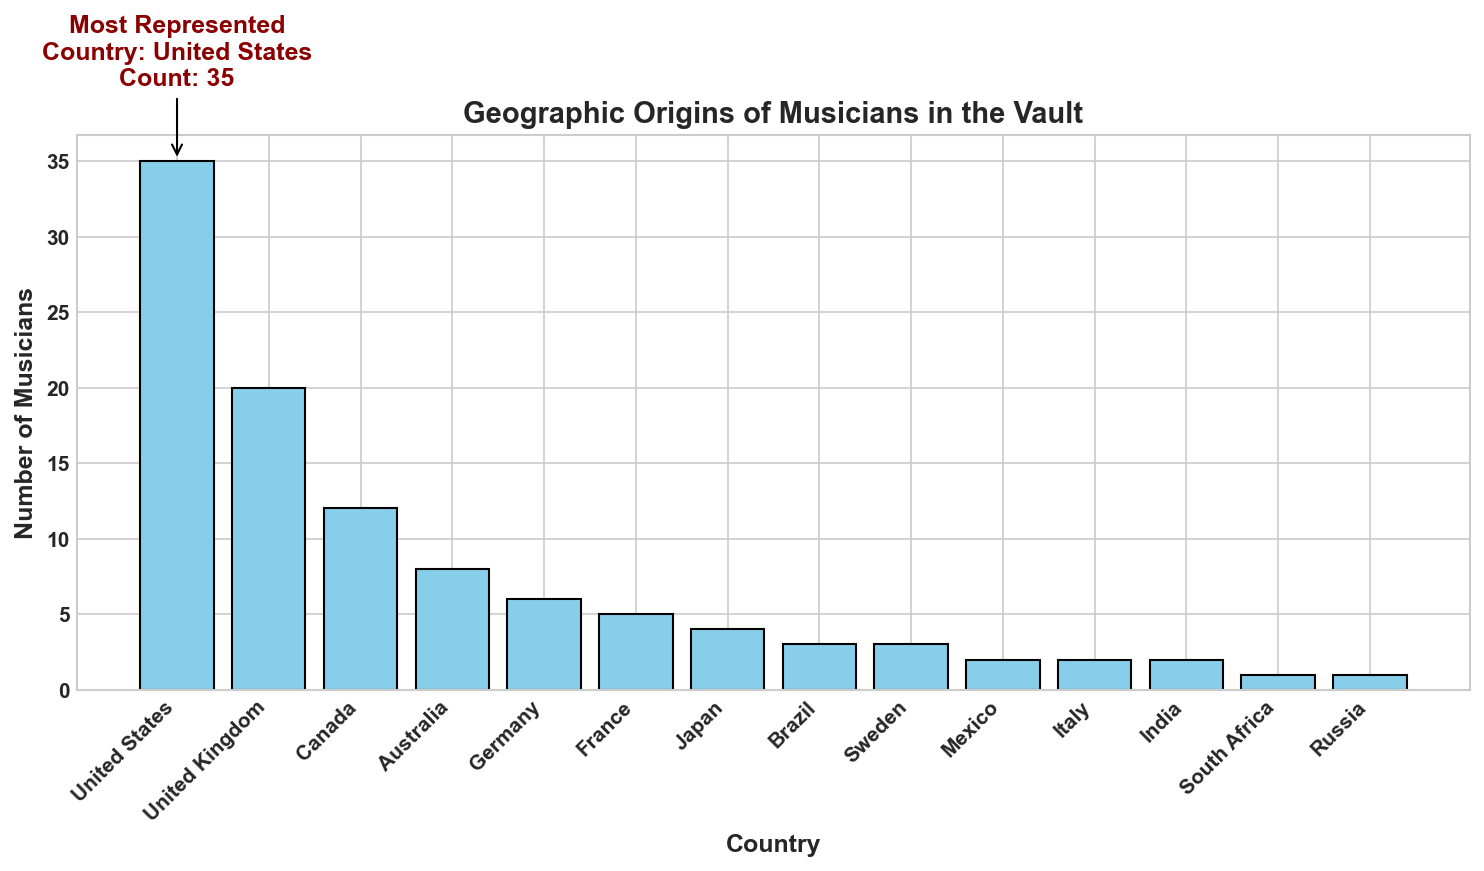Which country has the highest number of musicians? The figure includes an annotation pointing to the country with the highest count. The United States bar is the tallest and has an annotation indicating it is the most represented country with a count of 35.
Answer: United States What is the difference in the number of musicians between the United States and the United Kingdom? From the figure, the bar for the United States shows 35 musicians, while the bar for the United Kingdom shows 20 musicians. The difference is calculated as 35 - 20.
Answer: 15 How many countries have more than 5 musicians represented in the vault? By counting the bars that have a height greater than 5, we find that the United States, United Kingdom, Canada, Australia, and Germany meet this criterion. There are 5 countries.
Answer: 5 What is the total number of musicians from Germany, France, and Japan? The figure shows Germany with 6 musicians, France with 5 musicians, and Japan with 4 musicians. Summing these values gives 6 + 5 + 4 = 15.
Answer: 15 Does Canada have more musicians represented than Australia? The figure shows that the bar for Canada is taller than the bar for Australia, with 12 musicians for Canada and 8 for Australia.
Answer: Yes Which country has the fewest number of musicians, and what is that number? The shortest bars represent Russia and South Africa, each with 1 musician.
Answer: Russia and South Africa, 1 What is the average number of musicians from the countries Brazil, Sweden, Mexico, and Italy? Brazil has 3 musicians, Sweden has 3, Mexico has 2, and Italy has 2. The sum is 3 + 3 + 2 + 2 = 10 musicians. The average is 10/4 = 2.5.
Answer: 2.5 Between France and Japan, which country contributes more musicians to the vault and by how much? France contributes 5 musicians, and Japan contributes 4 musicians, so France contributes 5 - 4 = 1 more musician.
Answer: France, 1 What is the combined contribution of musicians from the United States, United Kingdom, and Canada? The United States has 35 musicians, United Kingdom has 20, and Canada has 12. Summing these, 35 + 20 + 12 = 67.
Answer: 67 Among the countries with exactly 2 musicians, list them and state their combined contributions. The figure shows Mexico, Italy, and India each have 2 musicians. Combining these, the total is 2 + 2 + 2 = 6 musicians.
Answer: Mexico, Italy, and India; 6 